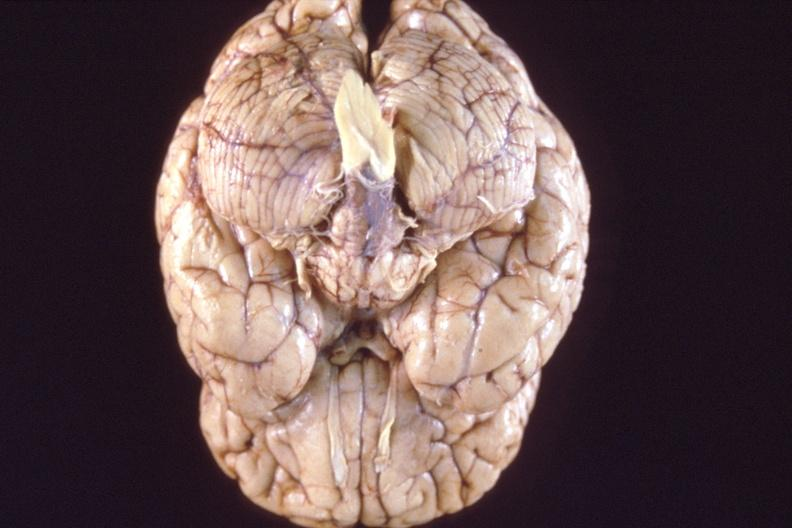does this image show brain, breast cancer metastasis to meninges?
Answer the question using a single word or phrase. Yes 